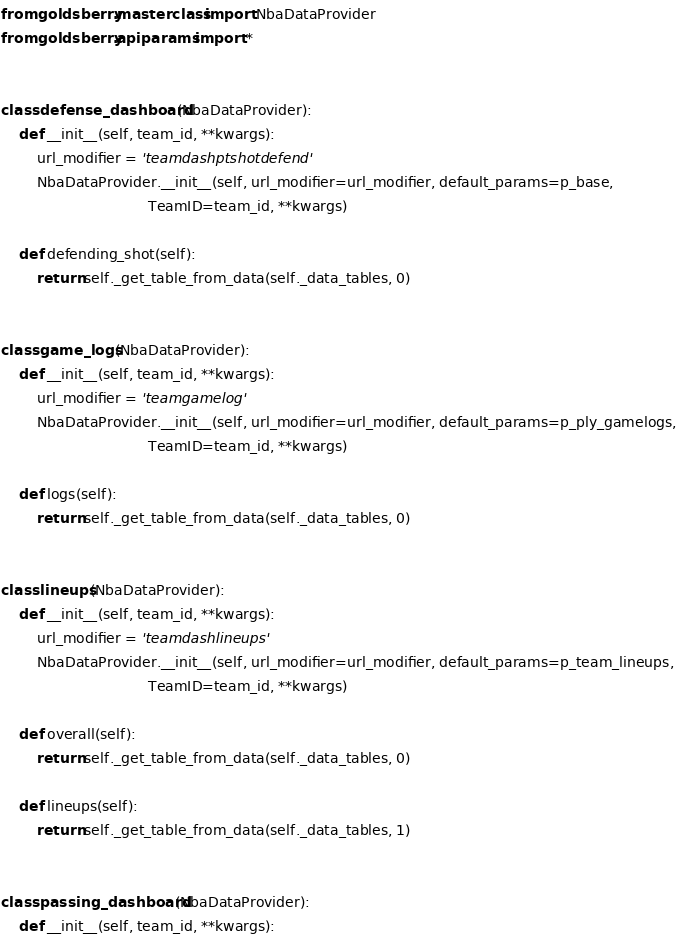Convert code to text. <code><loc_0><loc_0><loc_500><loc_500><_Python_>from goldsberry.masterclass import NbaDataProvider
from goldsberry.apiparams import *


class defense_dashboard(NbaDataProvider):
    def __init__(self, team_id, **kwargs):
        url_modifier = 'teamdashptshotdefend'
        NbaDataProvider.__init__(self, url_modifier=url_modifier, default_params=p_base,
                                 TeamID=team_id, **kwargs)

    def defending_shot(self):
        return self._get_table_from_data(self._data_tables, 0)


class game_logs(NbaDataProvider):
    def __init__(self, team_id, **kwargs):
        url_modifier = 'teamgamelog'
        NbaDataProvider.__init__(self, url_modifier=url_modifier, default_params=p_ply_gamelogs,
                                 TeamID=team_id, **kwargs)

    def logs(self):
        return self._get_table_from_data(self._data_tables, 0)


class lineups(NbaDataProvider):
    def __init__(self, team_id, **kwargs):
        url_modifier = 'teamdashlineups'
        NbaDataProvider.__init__(self, url_modifier=url_modifier, default_params=p_team_lineups,
                                 TeamID=team_id, **kwargs)

    def overall(self):
        return self._get_table_from_data(self._data_tables, 0)

    def lineups(self):
        return self._get_table_from_data(self._data_tables, 1)


class passing_dashboard(NbaDataProvider):
    def __init__(self, team_id, **kwargs):</code> 